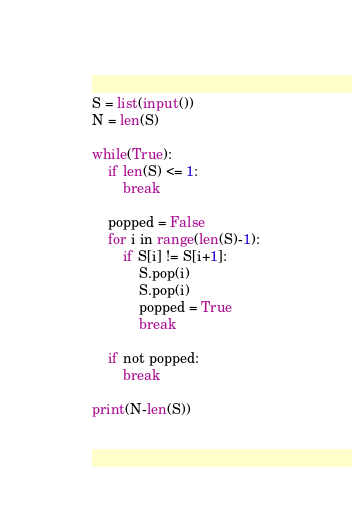Convert code to text. <code><loc_0><loc_0><loc_500><loc_500><_Python_>S = list(input())
N = len(S)

while(True):
    if len(S) <= 1:
        break

    popped = False
    for i in range(len(S)-1):
        if S[i] != S[i+1]:
            S.pop(i)
            S.pop(i)
            popped = True
            break

    if not popped:
        break

print(N-len(S))</code> 